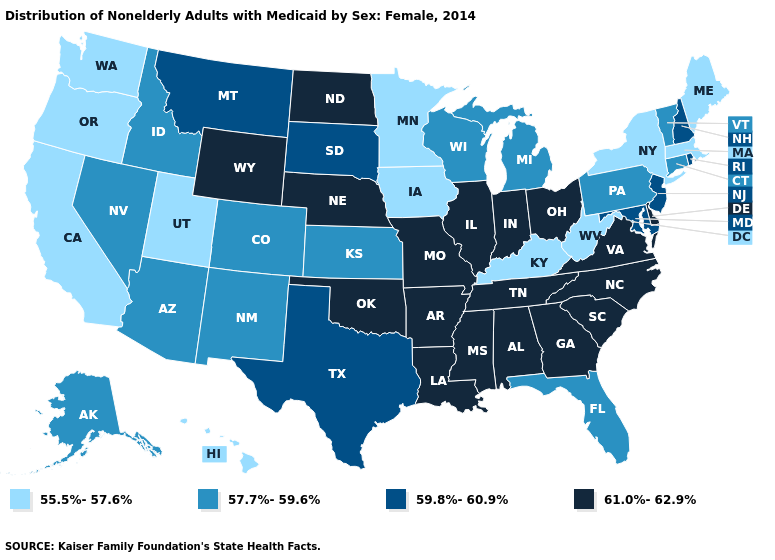Does the first symbol in the legend represent the smallest category?
Keep it brief. Yes. What is the value of Georgia?
Answer briefly. 61.0%-62.9%. Is the legend a continuous bar?
Answer briefly. No. Among the states that border Vermont , which have the lowest value?
Be succinct. Massachusetts, New York. Name the states that have a value in the range 57.7%-59.6%?
Answer briefly. Alaska, Arizona, Colorado, Connecticut, Florida, Idaho, Kansas, Michigan, Nevada, New Mexico, Pennsylvania, Vermont, Wisconsin. Among the states that border South Dakota , which have the lowest value?
Give a very brief answer. Iowa, Minnesota. Which states have the lowest value in the MidWest?
Answer briefly. Iowa, Minnesota. Does Virginia have the same value as South Carolina?
Concise answer only. Yes. Name the states that have a value in the range 55.5%-57.6%?
Give a very brief answer. California, Hawaii, Iowa, Kentucky, Maine, Massachusetts, Minnesota, New York, Oregon, Utah, Washington, West Virginia. What is the value of Alabama?
Concise answer only. 61.0%-62.9%. What is the value of Pennsylvania?
Be succinct. 57.7%-59.6%. How many symbols are there in the legend?
Keep it brief. 4. What is the highest value in the South ?
Answer briefly. 61.0%-62.9%. Does Iowa have the lowest value in the USA?
Concise answer only. Yes. What is the value of Michigan?
Keep it brief. 57.7%-59.6%. 